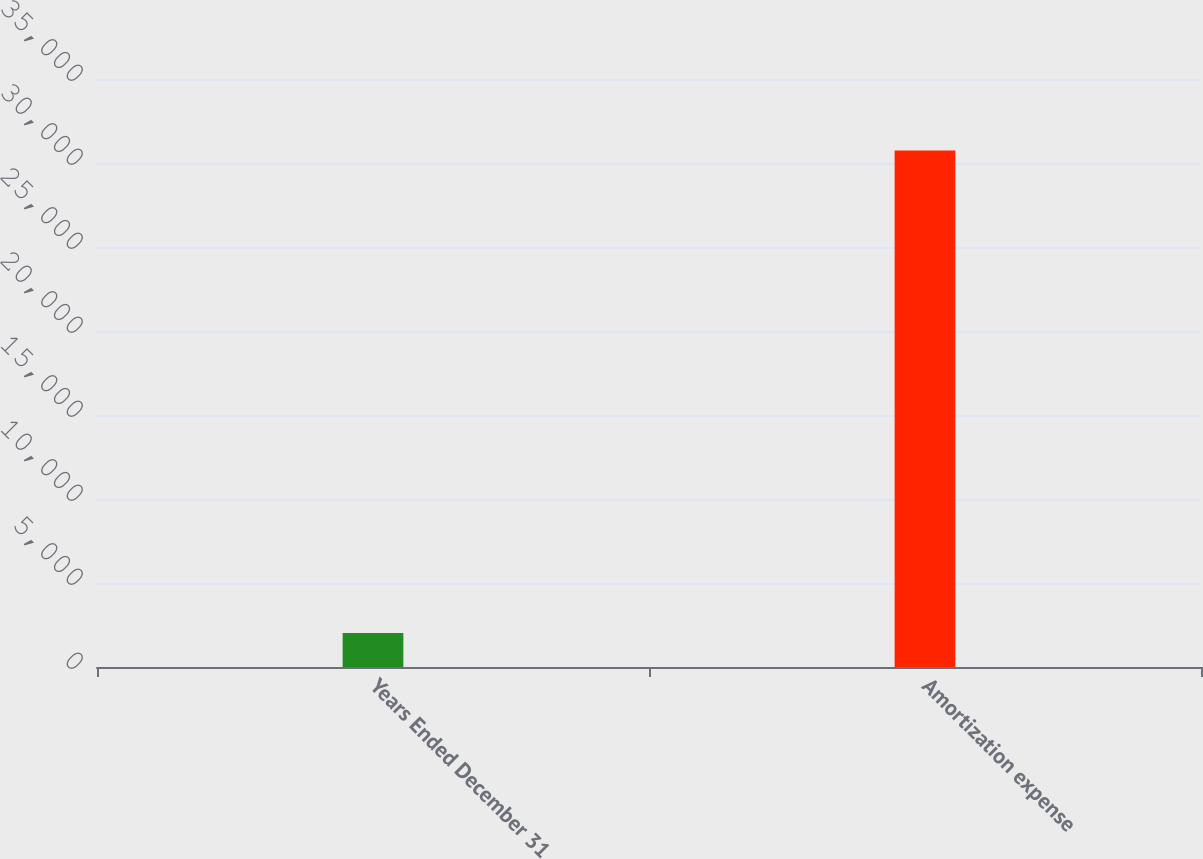Convert chart to OTSL. <chart><loc_0><loc_0><loc_500><loc_500><bar_chart><fcel>Years Ended December 31<fcel>Amortization expense<nl><fcel>2018<fcel>30745<nl></chart> 